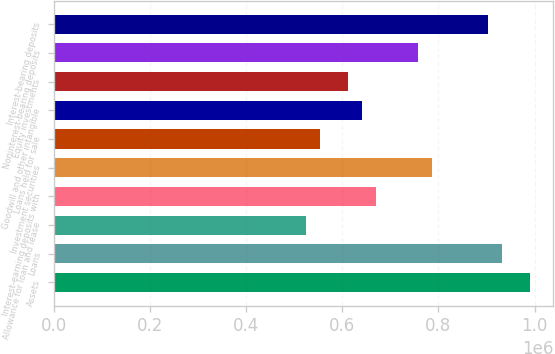Convert chart to OTSL. <chart><loc_0><loc_0><loc_500><loc_500><bar_chart><fcel>Assets<fcel>Loans<fcel>Allowance for loan and lease<fcel>Interest-earning deposits with<fcel>Investment securities<fcel>Loans held for sale<fcel>Goodwill and other intangible<fcel>Equity investments<fcel>Noninterest-bearing deposits<fcel>Interest-bearing deposits<nl><fcel>989674<fcel>931458<fcel>523945<fcel>669486<fcel>785918<fcel>553053<fcel>640378<fcel>611269<fcel>756810<fcel>902350<nl></chart> 